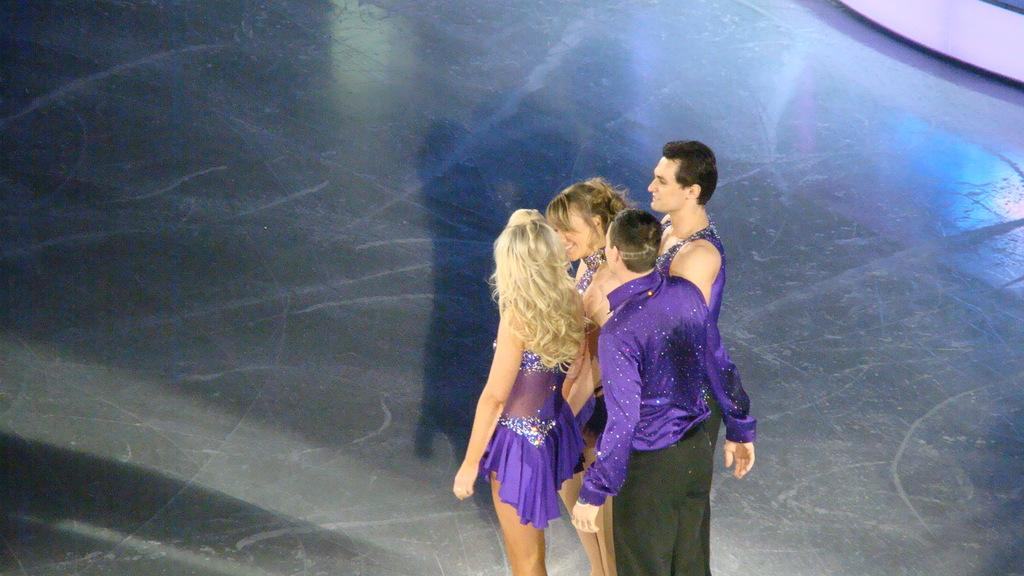What is the main subject of the image? The main subject of the image is a group of persons. What are the persons in the image doing? The persons are standing and smiling. What color are the dresses worn by the persons in the image? The persons are wearing purple color dresses. How many eyes can be seen on the chin of the person in the image? There are no eyes visible on the chin of any person in the image. 